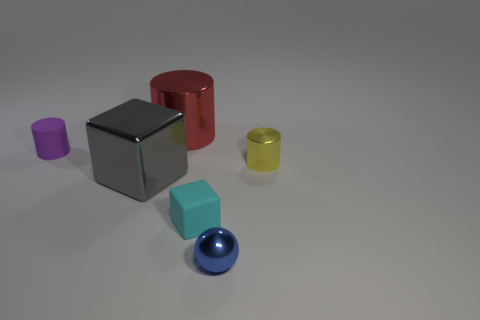There is a block that is behind the tiny cube; how big is it?
Provide a short and direct response. Large. There is a shiny cylinder that is behind the metal thing to the right of the small blue sphere; what number of small yellow things are on the left side of it?
Your answer should be very brief. 0. Are there any objects behind the large cube?
Provide a short and direct response. Yes. How many other things are the same size as the blue sphere?
Keep it short and to the point. 3. What is the tiny object that is both on the right side of the cyan cube and behind the small matte block made of?
Make the answer very short. Metal. There is a red thing that is behind the gray metal thing; is it the same shape as the matte thing in front of the tiny purple cylinder?
Keep it short and to the point. No. Is there any other thing that is made of the same material as the large gray cube?
Your answer should be compact. Yes. What shape is the big shiny object in front of the cylinder that is on the right side of the rubber object in front of the yellow cylinder?
Provide a short and direct response. Cube. How many other things are there of the same shape as the small yellow shiny thing?
Make the answer very short. 2. What is the color of the metal block that is the same size as the red metal cylinder?
Provide a short and direct response. Gray. 